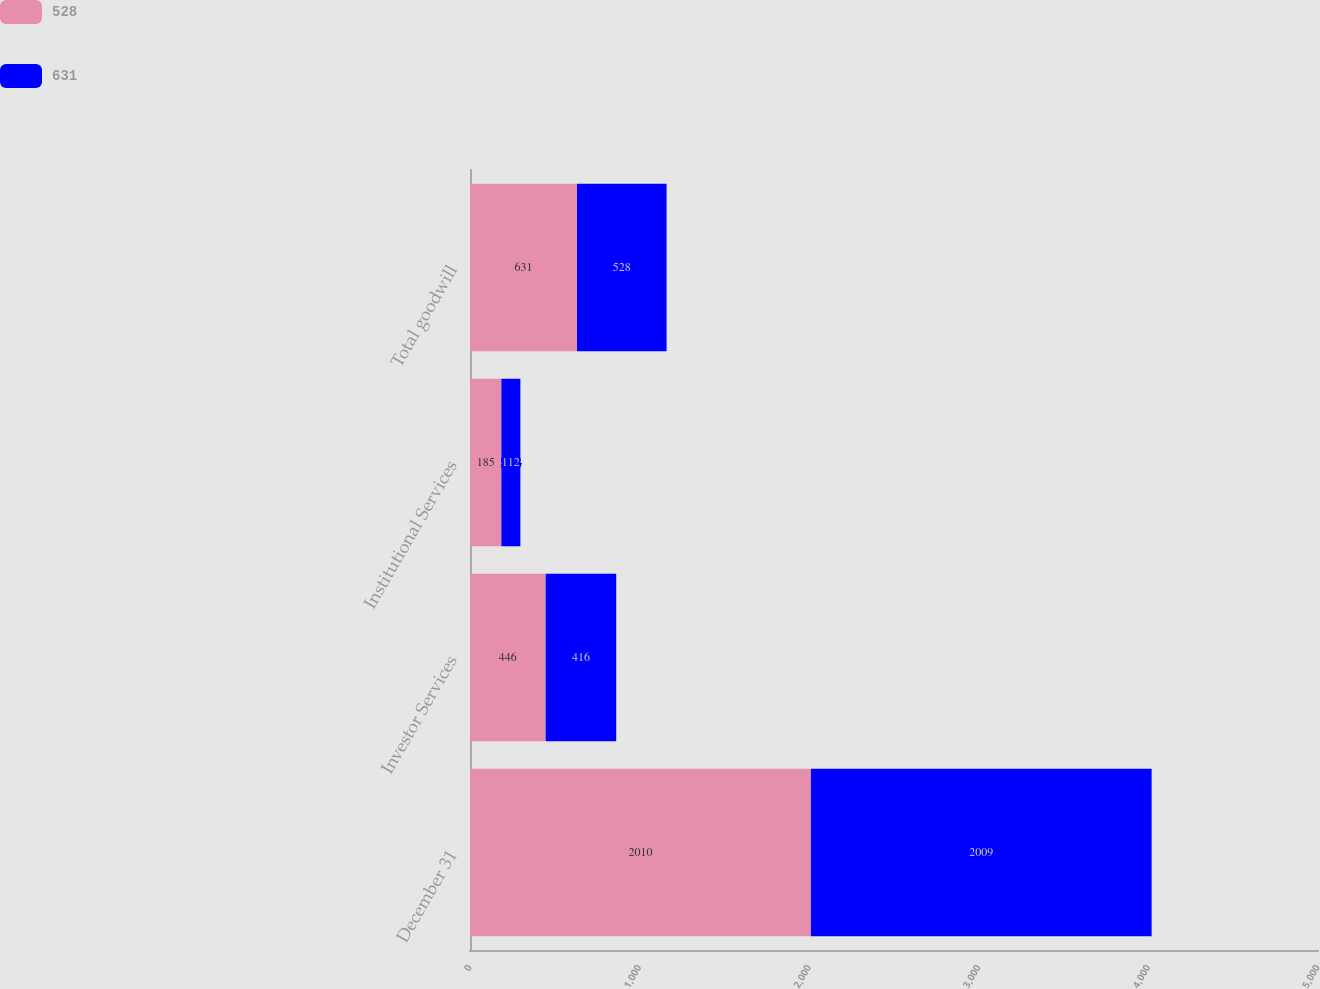Convert chart to OTSL. <chart><loc_0><loc_0><loc_500><loc_500><stacked_bar_chart><ecel><fcel>December 31<fcel>Investor Services<fcel>Institutional Services<fcel>Total goodwill<nl><fcel>528<fcel>2010<fcel>446<fcel>185<fcel>631<nl><fcel>631<fcel>2009<fcel>416<fcel>112<fcel>528<nl></chart> 